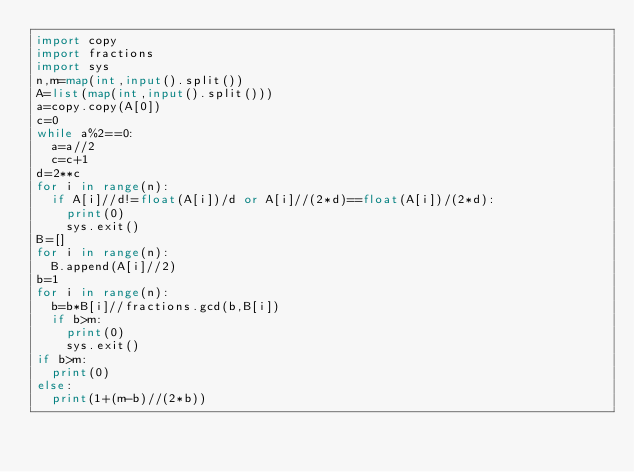<code> <loc_0><loc_0><loc_500><loc_500><_Python_>import copy
import fractions
import sys
n,m=map(int,input().split())
A=list(map(int,input().split()))
a=copy.copy(A[0])
c=0
while a%2==0:
  a=a//2
  c=c+1
d=2**c
for i in range(n):
  if A[i]//d!=float(A[i])/d or A[i]//(2*d)==float(A[i])/(2*d):
    print(0)
    sys.exit()
B=[]
for i in range(n):
  B.append(A[i]//2)
b=1
for i in range(n):
  b=b*B[i]//fractions.gcd(b,B[i])
  if b>m:
    print(0)
    sys.exit()
if b>m:
  print(0)
else:
  print(1+(m-b)//(2*b))</code> 